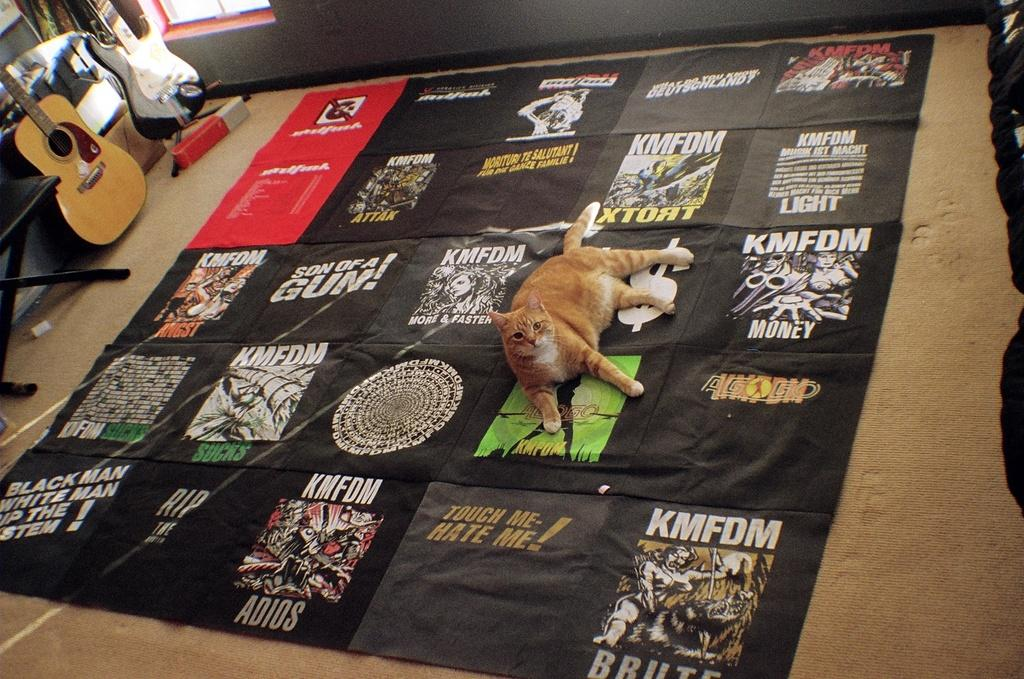What type of animal is on the floor in the image? There is a cat on the floor in the image. What musical instruments are in the left corner of the image? There are two guitars in the left corner of the image. What piece of furniture is in the left corner of the image? There is a chair in the left corner of the image. How many icicles are hanging from the cat's whiskers in the image? There are no icicles present in the image, as it is indoors and not cold enough for icicles to form. 